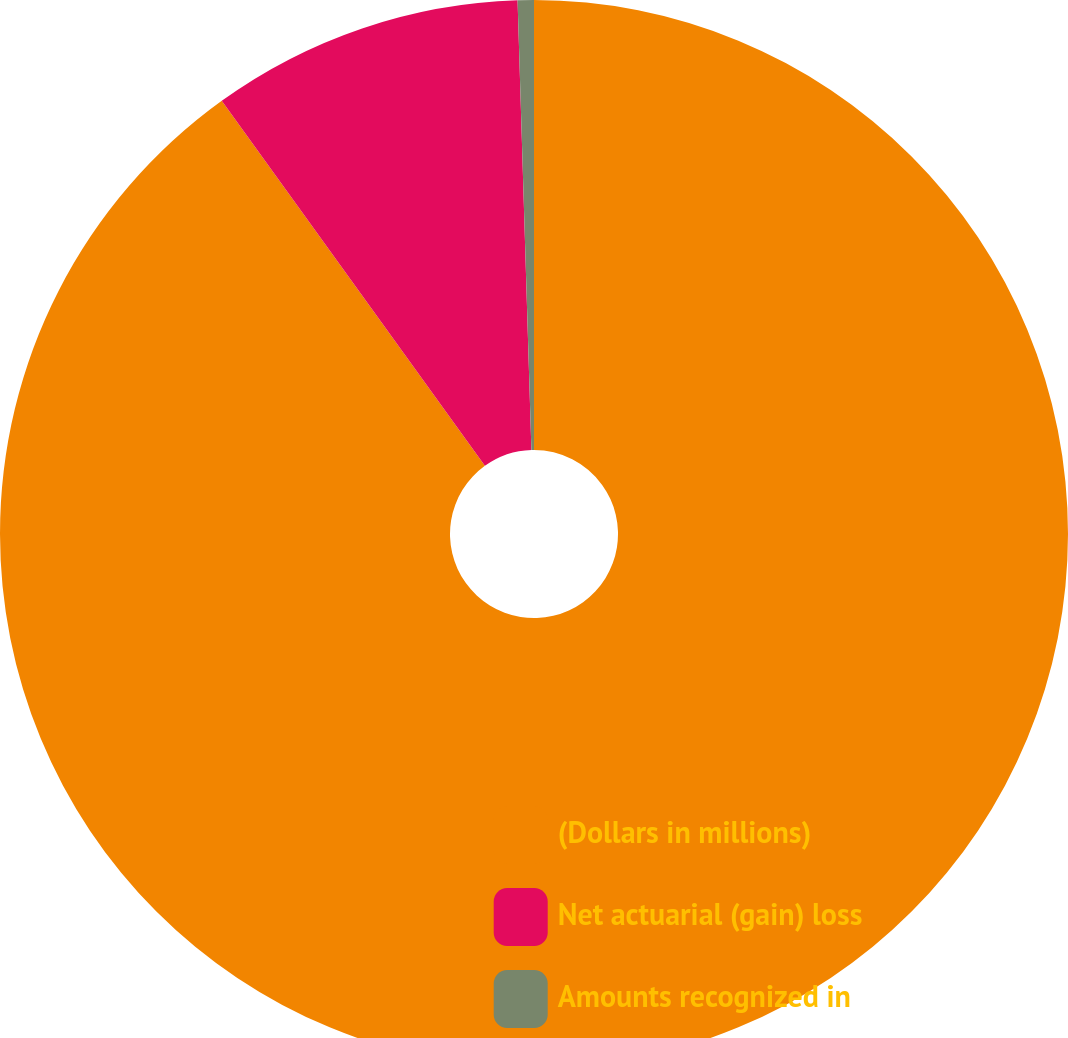Convert chart to OTSL. <chart><loc_0><loc_0><loc_500><loc_500><pie_chart><fcel>(Dollars in millions)<fcel>Net actuarial (gain) loss<fcel>Amounts recognized in<nl><fcel>90.06%<fcel>9.45%<fcel>0.49%<nl></chart> 